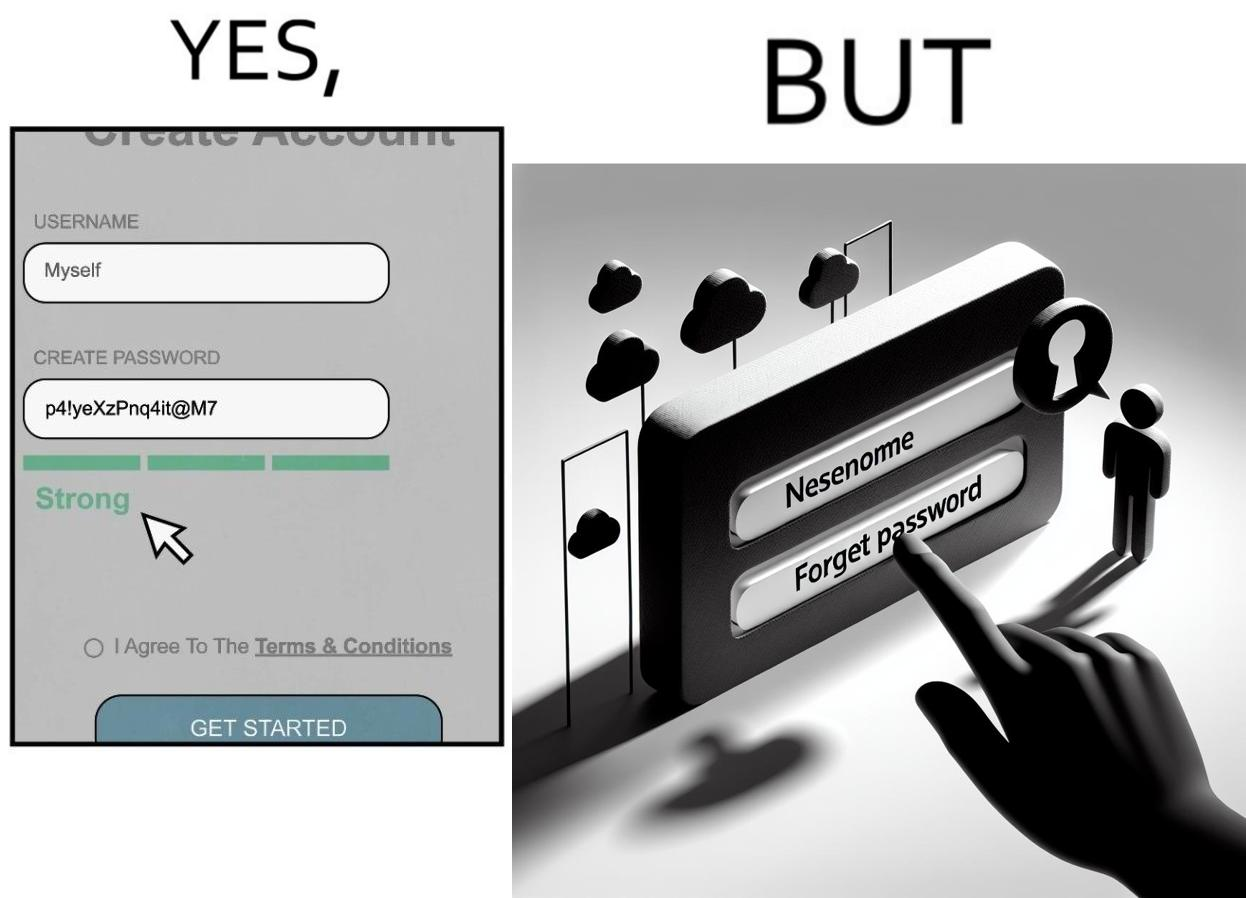Is this image satirical or non-satirical? Yes, this image is satirical. 